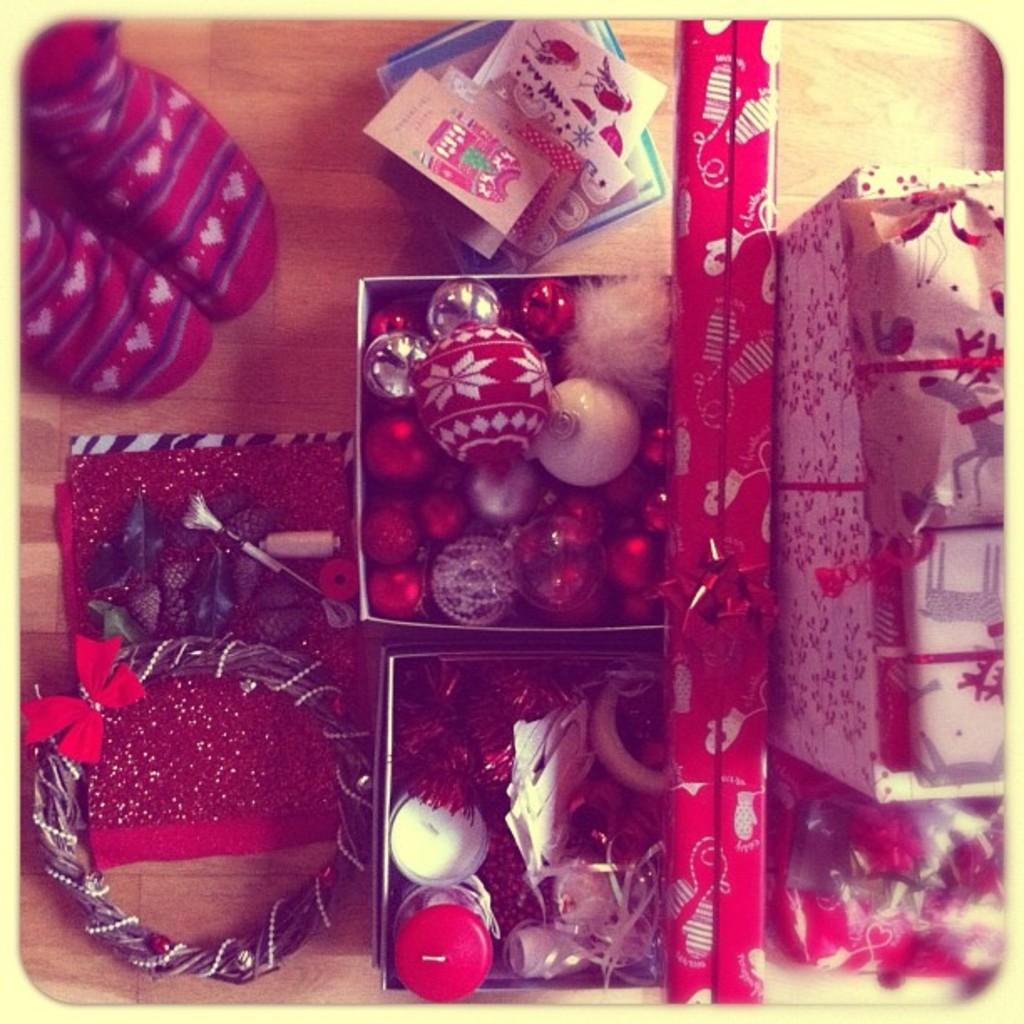Can you describe this image briefly? Here we can see boxes, decorative balls, cards, socks, and objects on a platform. 